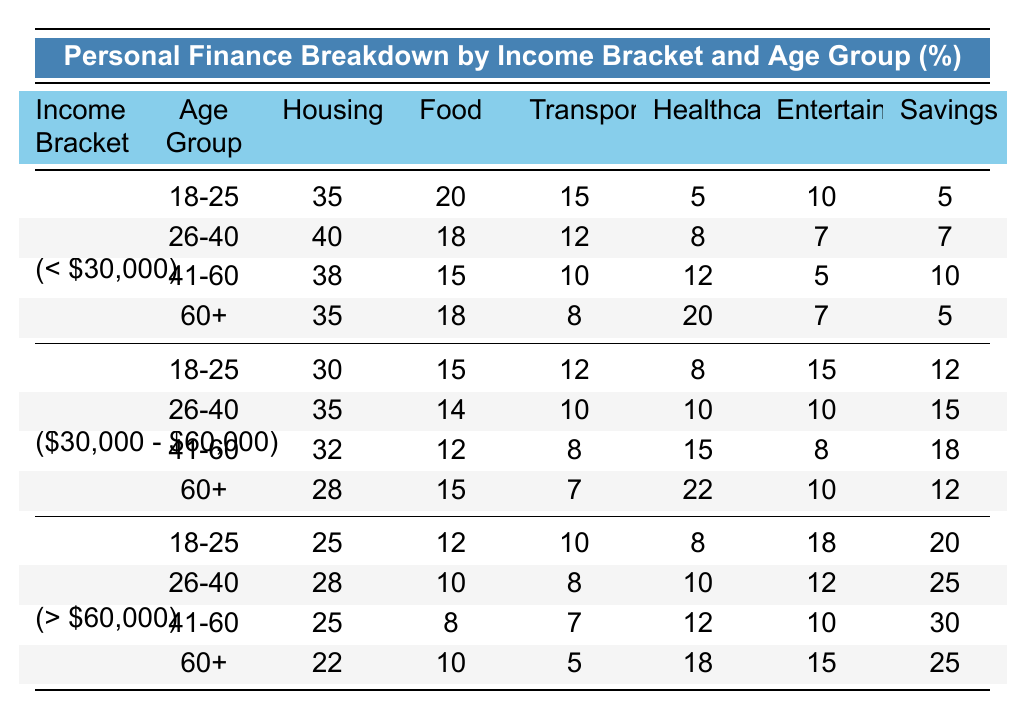What percentage of expenses are allocated to Food in the Low Income age group 26-40? In the Low Income bracket, for the age group 26-40, the percentage allocated to Food is 18.
Answer: 18 Which age group in the Middle Income bracket has the highest percentage for Savings? In the Middle Income bracket, the age group 41-60 has the highest percentage for Savings at 18%.
Answer: 18 What is the total percentage of expenses allocated to Entertainment for all age groups in the High Income bracket? In the High Income bracket, the Entertainment percentages for each age group are 18, 12, 10, and 15. Summing these values gives 18 + 12 + 10 + 15 = 55.
Answer: 55 True or False: The Healthcare expenses are highest for the Low Income age group 60+. For Low Income 60+, the Healthcare expense is 20, which is not higher than Middle Income 60+ (22) or High Income 60+ (18). Thus, the statement is false.
Answer: False In the category of Low Income, which age group has the lowest percentage for Savings? The age group 60+ in the Low Income bracket has a Savings percentage of 5, which is lower than the other groups.
Answer: 60+ What percentage more is allocated to Housing for the Low Income age group 41-60 compared to the High Income age group 41-60? In Low Income 41-60, the Housing percentage is 38, while in High Income 41-60, it is 25. The difference is 38 - 25 = 13, which is approximately 52% more than the High Income percentage (13/25 * 100).
Answer: 52% Which income bracket has the highest total percentage spent on Healthcare for the age group 60+? The Healthcare percentages for age group 60+ are 20% (Low Income), 22% (Middle Income), and 18% (High Income). The highest percentage is from Middle Income at 22%.
Answer: 22 What is the average percentage spent on Transportation across all age groups in the Middle Income bracket? The Transportation expenses are 12, 10, 8, and 7 for the respective age groups. Summing these values gives 12 + 10 + 8 + 7 = 37. Dividing by the number of age groups (4) gives 37 / 4 = 9.25.
Answer: 9.25 In terms of percentage, what is the difference in Entertainment expenses between the age groups 18-25 in Low Income and High Income? Entertainment expenses are 10% for Low Income 18-25 and 18% for High Income 18-25. The difference is 18 - 10 = 8%.
Answer: 8 Which age group in the Low Income bracket has the highest expenses in Transportation? In the Low Income bracket, the Transportation percentages for the age groups are 15 (18-25), 12 (26-40), 10 (41-60), and 8 (60+). The highest is 15%, in the 18-25 age group.
Answer: 18-25 True or False: The percentage of expenses on Food decreases as the age groups increase in the Middle Income bracket. The percentages for Food in the Middle Income are 15 (18-25), 14 (26-40), 12 (41-60), and 15 (60+), showing inconsistency. Thus, the statement is false.
Answer: False 